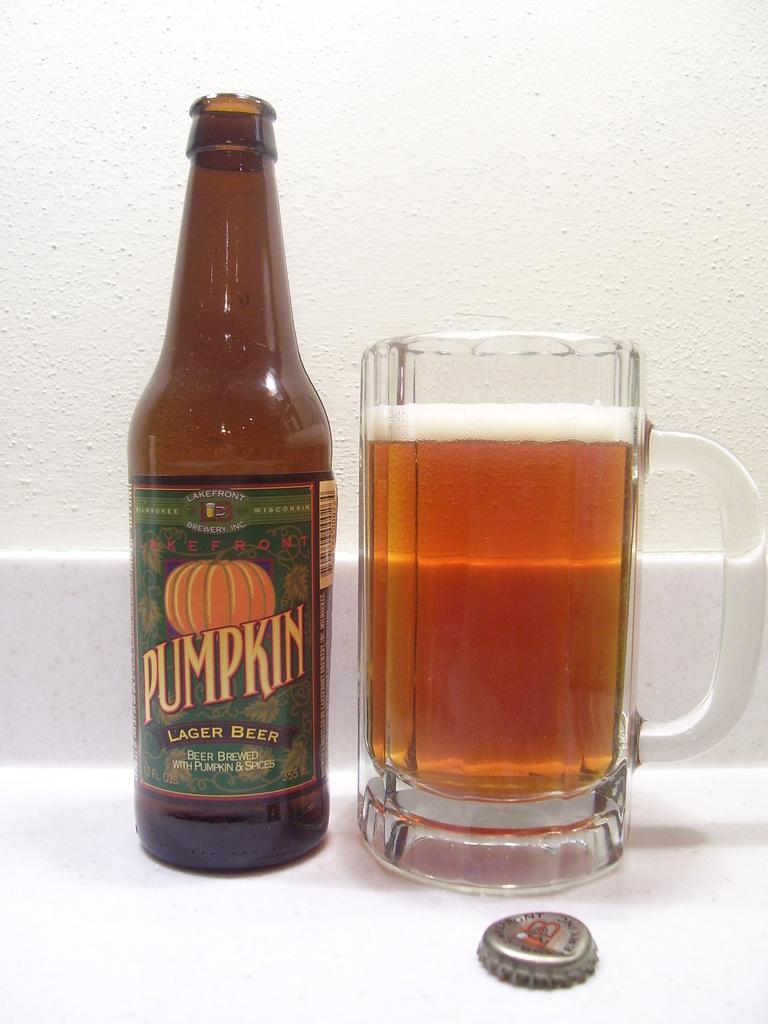Provide a one-sentence caption for the provided image. A bottle of Pumpkin Lager Beer and and glass of beer. 